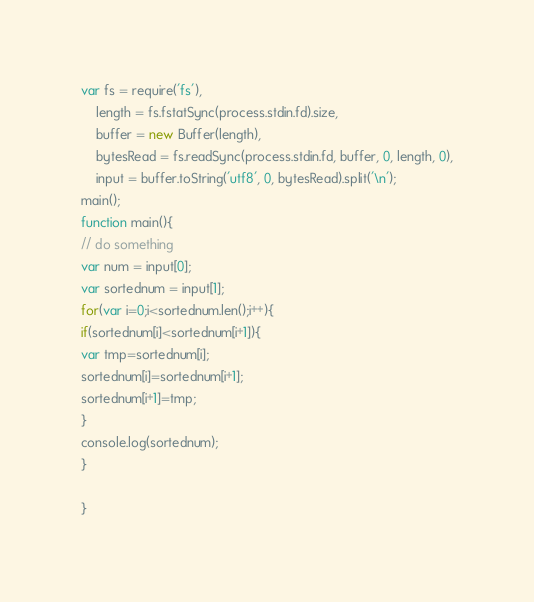Convert code to text. <code><loc_0><loc_0><loc_500><loc_500><_JavaScript_>var fs = require('fs'),
    length = fs.fstatSync(process.stdin.fd).size,
    buffer = new Buffer(length),
    bytesRead = fs.readSync(process.stdin.fd, buffer, 0, length, 0),
    input = buffer.toString('utf8', 0, bytesRead).split('\n');
main();
function main(){
// do something
var num = input[0];
var sortednum = input[1];
for(var i=0;i<sortednum.len();i++){
if(sortednum[i]<sortednum[i+1]){
var tmp=sortednum[i];
sortednum[i]=sortednum[i+1];
sortednum[i+1]=tmp;
}
console.log(sortednum);
}

}</code> 